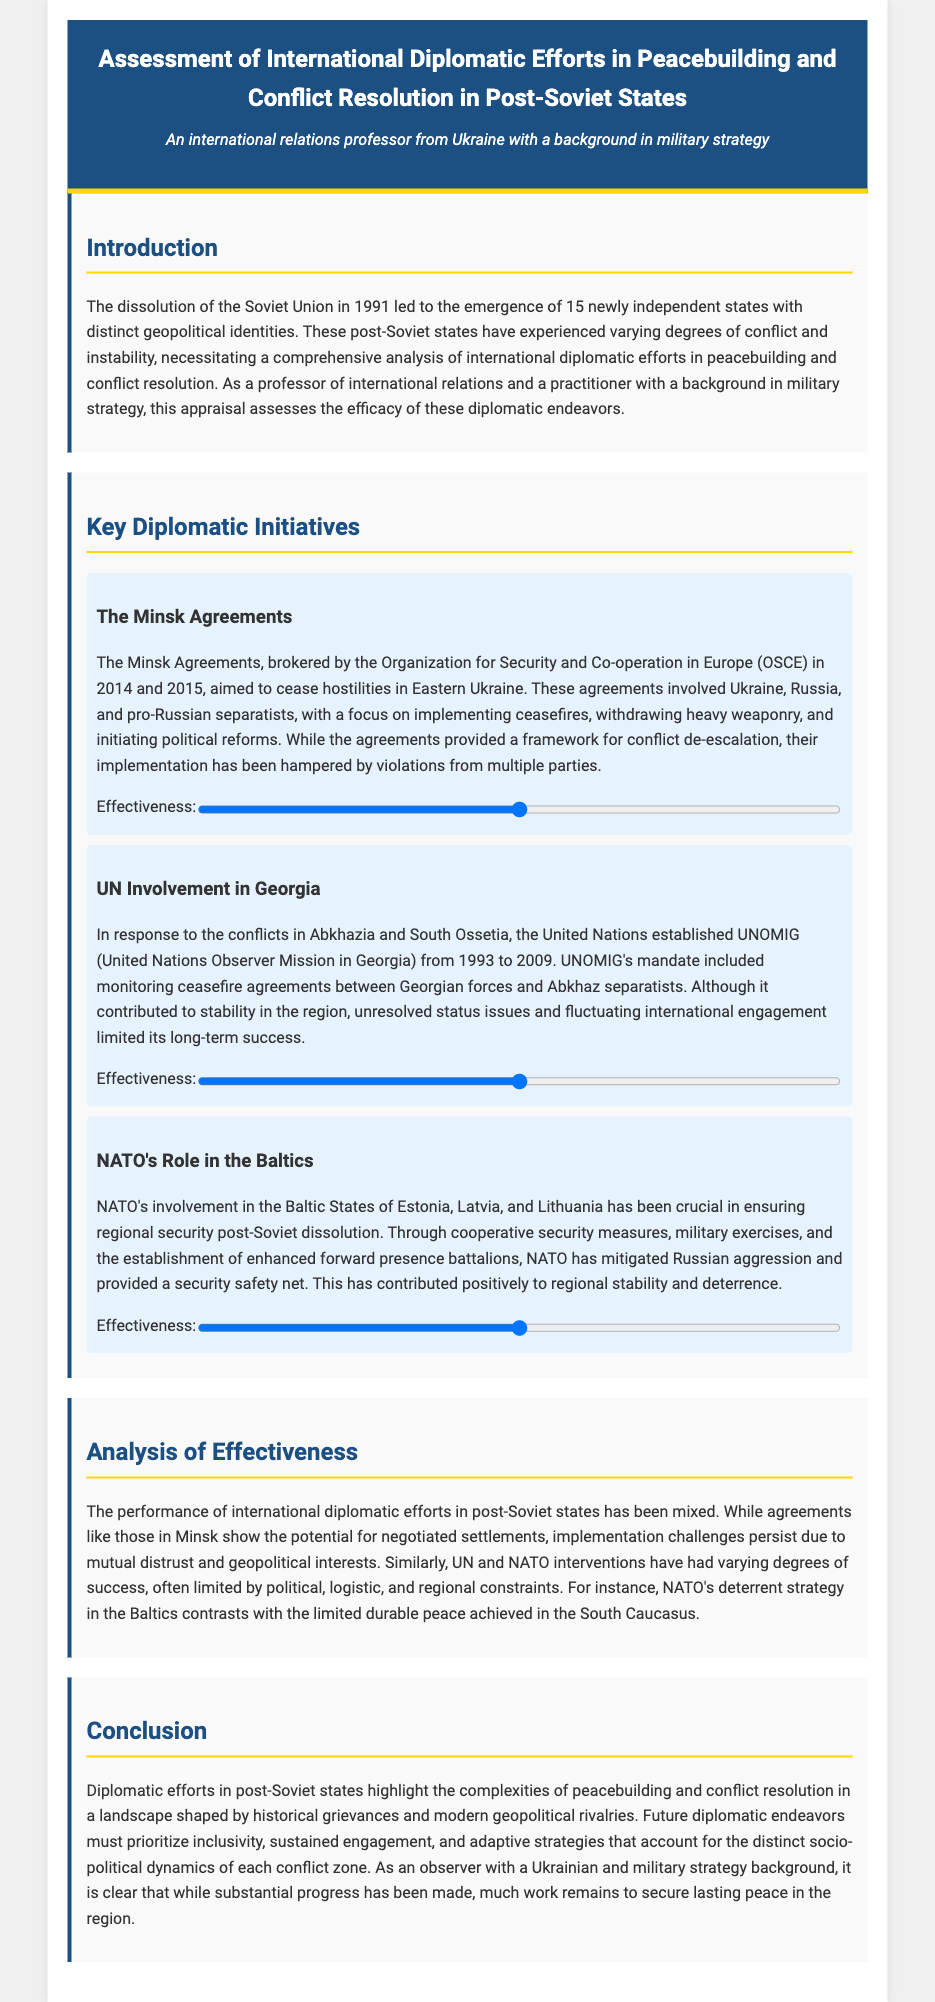what were the Minsk Agreements aimed at? The Minsk Agreements aimed to cease hostilities in Eastern Ukraine.
Answer: cease hostilities who brokered the Minsk Agreements? The Minsk Agreements were brokered by the Organization for Security and Co-operation in Europe.
Answer: OSCE what was the duration of UNOMIG's mandate in Georgia? UNOMIG was established from 1993 to 2009.
Answer: 16 years which states does NATO's role pertain to? NATO's involvement pertains to the Baltic States of Estonia, Latvia, and Lithuania.
Answer: Estonia, Latvia, Lithuania what is a major challenge faced by the Minsk Agreements? A major challenge faced by the Minsk Agreements is violations from multiple parties.
Answer: violations how effective is NATO's deterrent strategy in the Baltics described as? NATO's deterrent strategy is described as positive to regional stability and deterrence.
Answer: positive what kind of issues did UNOMIG address in post-Soviet states? UNOMIG's mandate included monitoring ceasefire agreements.
Answer: ceasefire agreements what does the analysis section suggest about the overall success of diplomatic efforts? The analysis suggests that the performance of international diplomatic efforts has been mixed.
Answer: mixed what key element must future diplomatic endeavors prioritize according to the conclusion? Future diplomatic endeavors must prioritize inclusivity.
Answer: inclusivity 